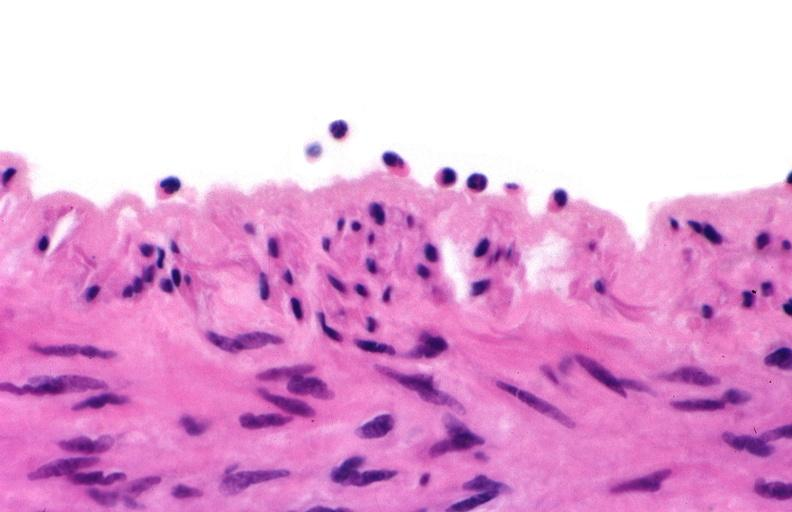s cranial artery present?
Answer the question using a single word or phrase. No 